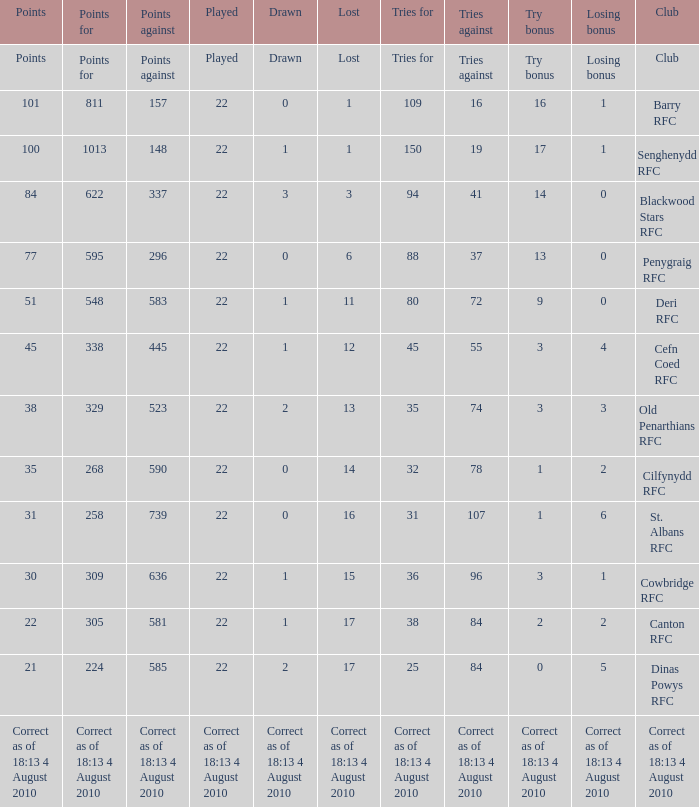Give me the full table as a dictionary. {'header': ['Points', 'Points for', 'Points against', 'Played', 'Drawn', 'Lost', 'Tries for', 'Tries against', 'Try bonus', 'Losing bonus', 'Club'], 'rows': [['Points', 'Points for', 'Points against', 'Played', 'Drawn', 'Lost', 'Tries for', 'Tries against', 'Try bonus', 'Losing bonus', 'Club'], ['101', '811', '157', '22', '0', '1', '109', '16', '16', '1', 'Barry RFC'], ['100', '1013', '148', '22', '1', '1', '150', '19', '17', '1', 'Senghenydd RFC'], ['84', '622', '337', '22', '3', '3', '94', '41', '14', '0', 'Blackwood Stars RFC'], ['77', '595', '296', '22', '0', '6', '88', '37', '13', '0', 'Penygraig RFC'], ['51', '548', '583', '22', '1', '11', '80', '72', '9', '0', 'Deri RFC'], ['45', '338', '445', '22', '1', '12', '45', '55', '3', '4', 'Cefn Coed RFC'], ['38', '329', '523', '22', '2', '13', '35', '74', '3', '3', 'Old Penarthians RFC'], ['35', '268', '590', '22', '0', '14', '32', '78', '1', '2', 'Cilfynydd RFC'], ['31', '258', '739', '22', '0', '16', '31', '107', '1', '6', 'St. Albans RFC'], ['30', '309', '636', '22', '1', '15', '36', '96', '3', '1', 'Cowbridge RFC'], ['22', '305', '581', '22', '1', '17', '38', '84', '2', '2', 'Canton RFC'], ['21', '224', '585', '22', '2', '17', '25', '84', '0', '5', 'Dinas Powys RFC'], ['Correct as of 18:13 4 August 2010', 'Correct as of 18:13 4 August 2010', 'Correct as of 18:13 4 August 2010', 'Correct as of 18:13 4 August 2010', 'Correct as of 18:13 4 August 2010', 'Correct as of 18:13 4 August 2010', 'Correct as of 18:13 4 August 2010', 'Correct as of 18:13 4 August 2010', 'Correct as of 18:13 4 August 2010', 'Correct as of 18:13 4 August 2010', 'Correct as of 18:13 4 August 2010']]} What is the losing bonus when drawn was 0, and there were 101 points? 1.0. 